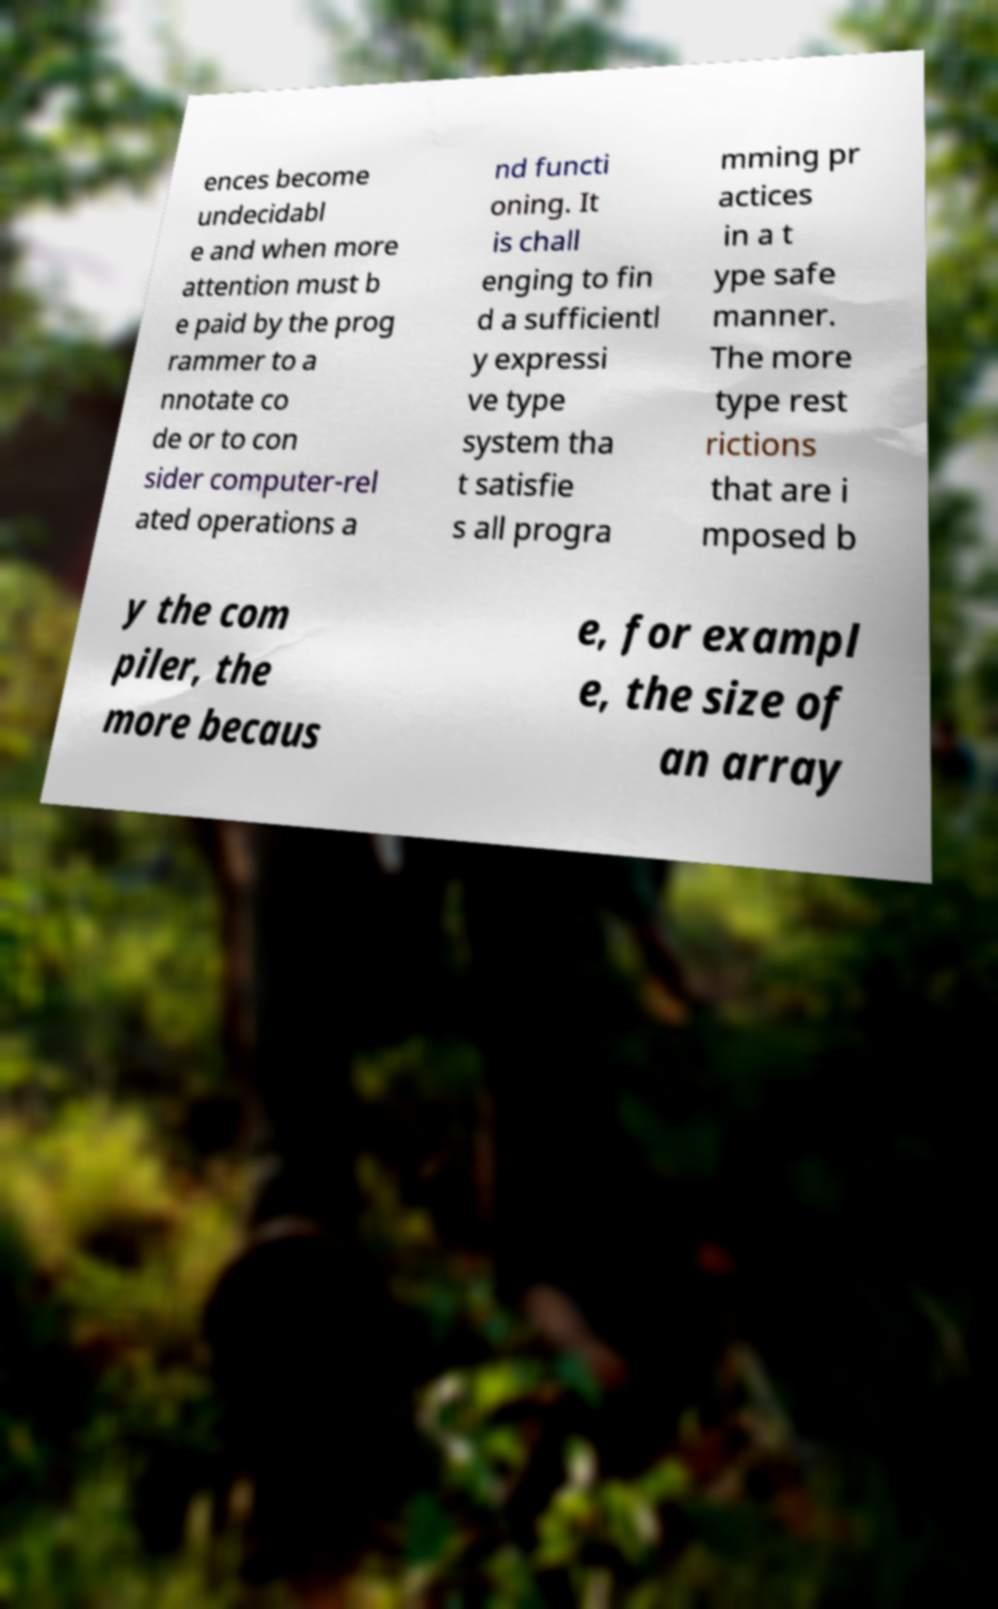What messages or text are displayed in this image? I need them in a readable, typed format. ences become undecidabl e and when more attention must b e paid by the prog rammer to a nnotate co de or to con sider computer-rel ated operations a nd functi oning. It is chall enging to fin d a sufficientl y expressi ve type system tha t satisfie s all progra mming pr actices in a t ype safe manner. The more type rest rictions that are i mposed b y the com piler, the more becaus e, for exampl e, the size of an array 